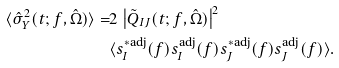<formula> <loc_0><loc_0><loc_500><loc_500>\langle \hat { \sigma } _ { Y } ^ { 2 } ( t ; f , \hat { \Omega } ) \rangle = & 2 \, \left | \tilde { Q } _ { I J } ( t ; f , \hat { \Omega } ) \right | ^ { 2 } \\ & \langle s _ { I } ^ { * \text {adj} } ( f ) s _ { I } ^ { \text {adj} } ( f ) s _ { J } ^ { * \text {adj} } ( f ) s _ { J } ^ { \text {adj} } ( f ) \rangle .</formula> 